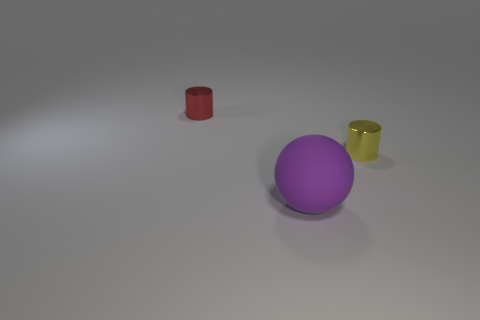There is a cylinder that is in front of the red thing; what color is it? yellow 